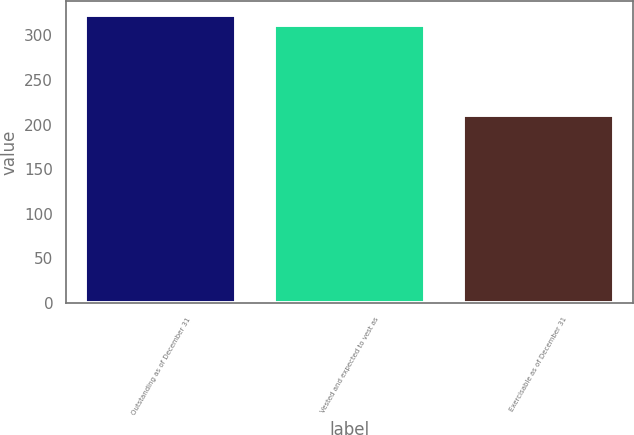Convert chart. <chart><loc_0><loc_0><loc_500><loc_500><bar_chart><fcel>Outstanding as of December 31<fcel>Vested and expected to vest as<fcel>Exercisable as of December 31<nl><fcel>322.2<fcel>312.04<fcel>210.85<nl></chart> 